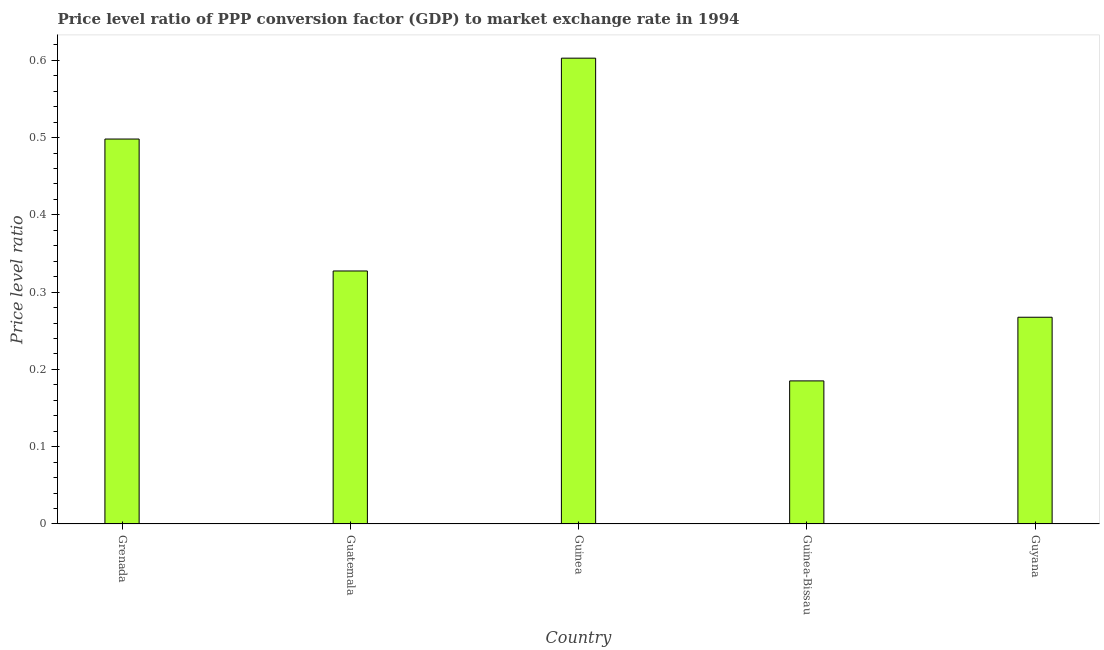Does the graph contain grids?
Make the answer very short. No. What is the title of the graph?
Give a very brief answer. Price level ratio of PPP conversion factor (GDP) to market exchange rate in 1994. What is the label or title of the X-axis?
Your answer should be very brief. Country. What is the label or title of the Y-axis?
Your answer should be very brief. Price level ratio. What is the price level ratio in Guinea-Bissau?
Keep it short and to the point. 0.19. Across all countries, what is the maximum price level ratio?
Provide a succinct answer. 0.6. Across all countries, what is the minimum price level ratio?
Make the answer very short. 0.19. In which country was the price level ratio maximum?
Provide a succinct answer. Guinea. In which country was the price level ratio minimum?
Ensure brevity in your answer.  Guinea-Bissau. What is the sum of the price level ratio?
Keep it short and to the point. 1.88. What is the difference between the price level ratio in Guatemala and Guyana?
Offer a terse response. 0.06. What is the average price level ratio per country?
Your answer should be very brief. 0.38. What is the median price level ratio?
Provide a succinct answer. 0.33. In how many countries, is the price level ratio greater than 0.1 ?
Ensure brevity in your answer.  5. What is the ratio of the price level ratio in Guinea-Bissau to that in Guyana?
Make the answer very short. 0.69. Is the price level ratio in Guinea less than that in Guyana?
Your answer should be very brief. No. What is the difference between the highest and the second highest price level ratio?
Make the answer very short. 0.1. What is the difference between the highest and the lowest price level ratio?
Offer a terse response. 0.42. In how many countries, is the price level ratio greater than the average price level ratio taken over all countries?
Provide a short and direct response. 2. Are all the bars in the graph horizontal?
Provide a succinct answer. No. How many countries are there in the graph?
Keep it short and to the point. 5. What is the difference between two consecutive major ticks on the Y-axis?
Provide a succinct answer. 0.1. Are the values on the major ticks of Y-axis written in scientific E-notation?
Offer a terse response. No. What is the Price level ratio in Grenada?
Provide a short and direct response. 0.5. What is the Price level ratio in Guatemala?
Keep it short and to the point. 0.33. What is the Price level ratio in Guinea?
Keep it short and to the point. 0.6. What is the Price level ratio of Guinea-Bissau?
Make the answer very short. 0.19. What is the Price level ratio of Guyana?
Offer a terse response. 0.27. What is the difference between the Price level ratio in Grenada and Guatemala?
Make the answer very short. 0.17. What is the difference between the Price level ratio in Grenada and Guinea?
Make the answer very short. -0.1. What is the difference between the Price level ratio in Grenada and Guinea-Bissau?
Provide a succinct answer. 0.31. What is the difference between the Price level ratio in Grenada and Guyana?
Your answer should be compact. 0.23. What is the difference between the Price level ratio in Guatemala and Guinea?
Give a very brief answer. -0.28. What is the difference between the Price level ratio in Guatemala and Guinea-Bissau?
Keep it short and to the point. 0.14. What is the difference between the Price level ratio in Guatemala and Guyana?
Keep it short and to the point. 0.06. What is the difference between the Price level ratio in Guinea and Guinea-Bissau?
Your response must be concise. 0.42. What is the difference between the Price level ratio in Guinea and Guyana?
Your answer should be very brief. 0.34. What is the difference between the Price level ratio in Guinea-Bissau and Guyana?
Your answer should be compact. -0.08. What is the ratio of the Price level ratio in Grenada to that in Guatemala?
Your answer should be very brief. 1.52. What is the ratio of the Price level ratio in Grenada to that in Guinea?
Make the answer very short. 0.83. What is the ratio of the Price level ratio in Grenada to that in Guinea-Bissau?
Offer a very short reply. 2.69. What is the ratio of the Price level ratio in Grenada to that in Guyana?
Your answer should be compact. 1.86. What is the ratio of the Price level ratio in Guatemala to that in Guinea?
Provide a succinct answer. 0.54. What is the ratio of the Price level ratio in Guatemala to that in Guinea-Bissau?
Provide a short and direct response. 1.77. What is the ratio of the Price level ratio in Guatemala to that in Guyana?
Your response must be concise. 1.22. What is the ratio of the Price level ratio in Guinea to that in Guinea-Bissau?
Offer a very short reply. 3.26. What is the ratio of the Price level ratio in Guinea to that in Guyana?
Ensure brevity in your answer.  2.25. What is the ratio of the Price level ratio in Guinea-Bissau to that in Guyana?
Ensure brevity in your answer.  0.69. 